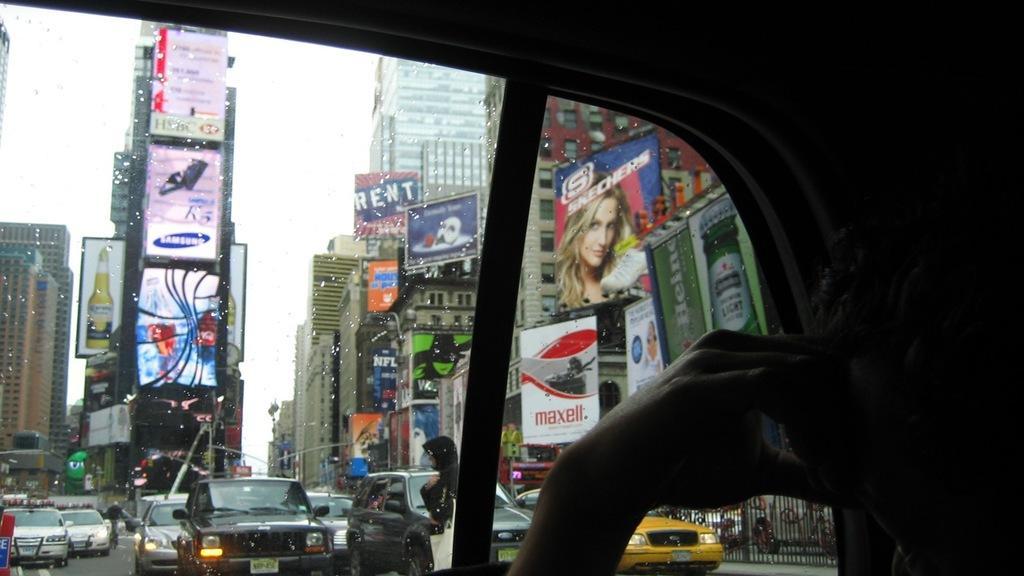How would you summarize this image in a sentence or two? In this image we can see a person inside a vehicle. Through the glass of the vehicle we can see vehicles on the road, buildings, screens and banners with text and images. In the background there is sky. 